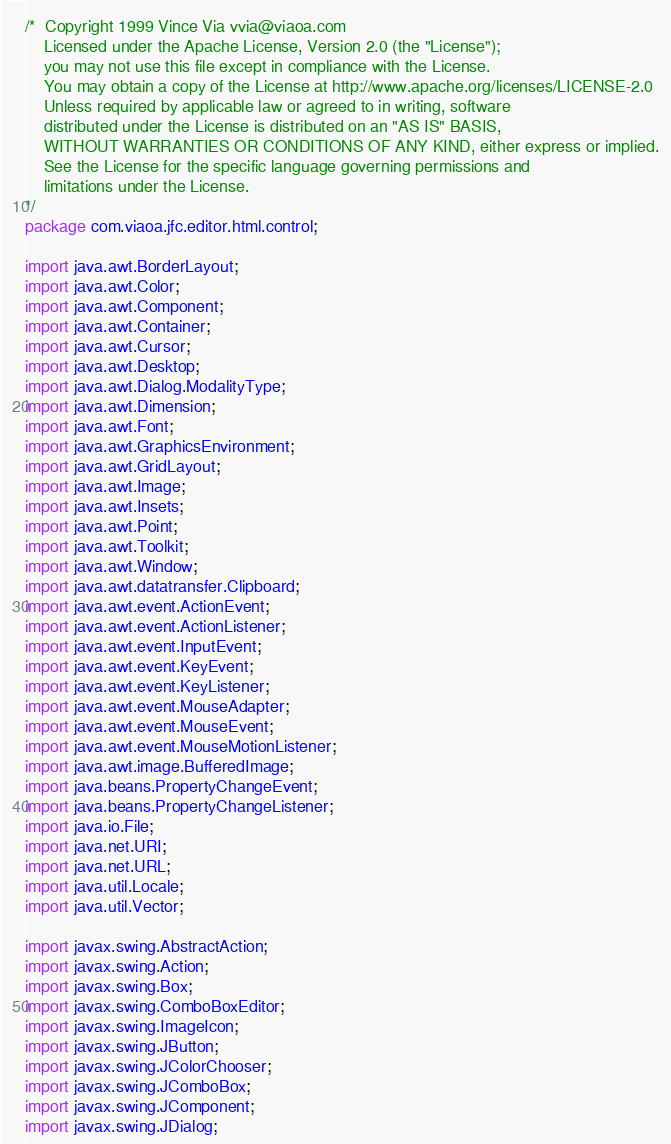<code> <loc_0><loc_0><loc_500><loc_500><_Java_>/*  Copyright 1999 Vince Via vvia@viaoa.com
    Licensed under the Apache License, Version 2.0 (the "License");
    you may not use this file except in compliance with the License.
    You may obtain a copy of the License at http://www.apache.org/licenses/LICENSE-2.0
    Unless required by applicable law or agreed to in writing, software
    distributed under the License is distributed on an "AS IS" BASIS,
    WITHOUT WARRANTIES OR CONDITIONS OF ANY KIND, either express or implied.
    See the License for the specific language governing permissions and
    limitations under the License.
*/
package com.viaoa.jfc.editor.html.control;

import java.awt.BorderLayout;
import java.awt.Color;
import java.awt.Component;
import java.awt.Container;
import java.awt.Cursor;
import java.awt.Desktop;
import java.awt.Dialog.ModalityType;
import java.awt.Dimension;
import java.awt.Font;
import java.awt.GraphicsEnvironment;
import java.awt.GridLayout;
import java.awt.Image;
import java.awt.Insets;
import java.awt.Point;
import java.awt.Toolkit;
import java.awt.Window;
import java.awt.datatransfer.Clipboard;
import java.awt.event.ActionEvent;
import java.awt.event.ActionListener;
import java.awt.event.InputEvent;
import java.awt.event.KeyEvent;
import java.awt.event.KeyListener;
import java.awt.event.MouseAdapter;
import java.awt.event.MouseEvent;
import java.awt.event.MouseMotionListener;
import java.awt.image.BufferedImage;
import java.beans.PropertyChangeEvent;
import java.beans.PropertyChangeListener;
import java.io.File;
import java.net.URI;
import java.net.URL;
import java.util.Locale;
import java.util.Vector;

import javax.swing.AbstractAction;
import javax.swing.Action;
import javax.swing.Box;
import javax.swing.ComboBoxEditor;
import javax.swing.ImageIcon;
import javax.swing.JButton;
import javax.swing.JColorChooser;
import javax.swing.JComboBox;
import javax.swing.JComponent;
import javax.swing.JDialog;</code> 